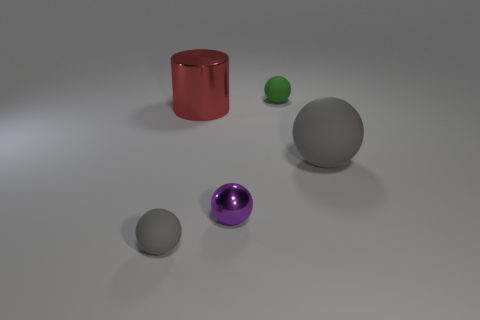What is the shape of the other tiny object that is made of the same material as the red thing?
Your answer should be very brief. Sphere. Is there any other thing that has the same shape as the purple shiny thing?
Ensure brevity in your answer.  Yes. Do the gray object that is left of the green object and the green ball have the same material?
Give a very brief answer. Yes. There is a gray ball that is left of the large gray ball; what is its material?
Your answer should be very brief. Rubber. There is a gray rubber object that is in front of the gray sphere on the right side of the tiny purple thing; how big is it?
Ensure brevity in your answer.  Small. How many other shiny balls have the same size as the metal ball?
Ensure brevity in your answer.  0. Is the color of the small matte thing behind the small purple metallic sphere the same as the small object that is on the left side of the red metallic cylinder?
Offer a terse response. No. Are there any purple metal spheres behind the shiny cylinder?
Keep it short and to the point. No. There is a rubber thing that is both in front of the large cylinder and right of the small gray ball; what color is it?
Give a very brief answer. Gray. Are there any large rubber objects of the same color as the tiny shiny ball?
Offer a terse response. No. 